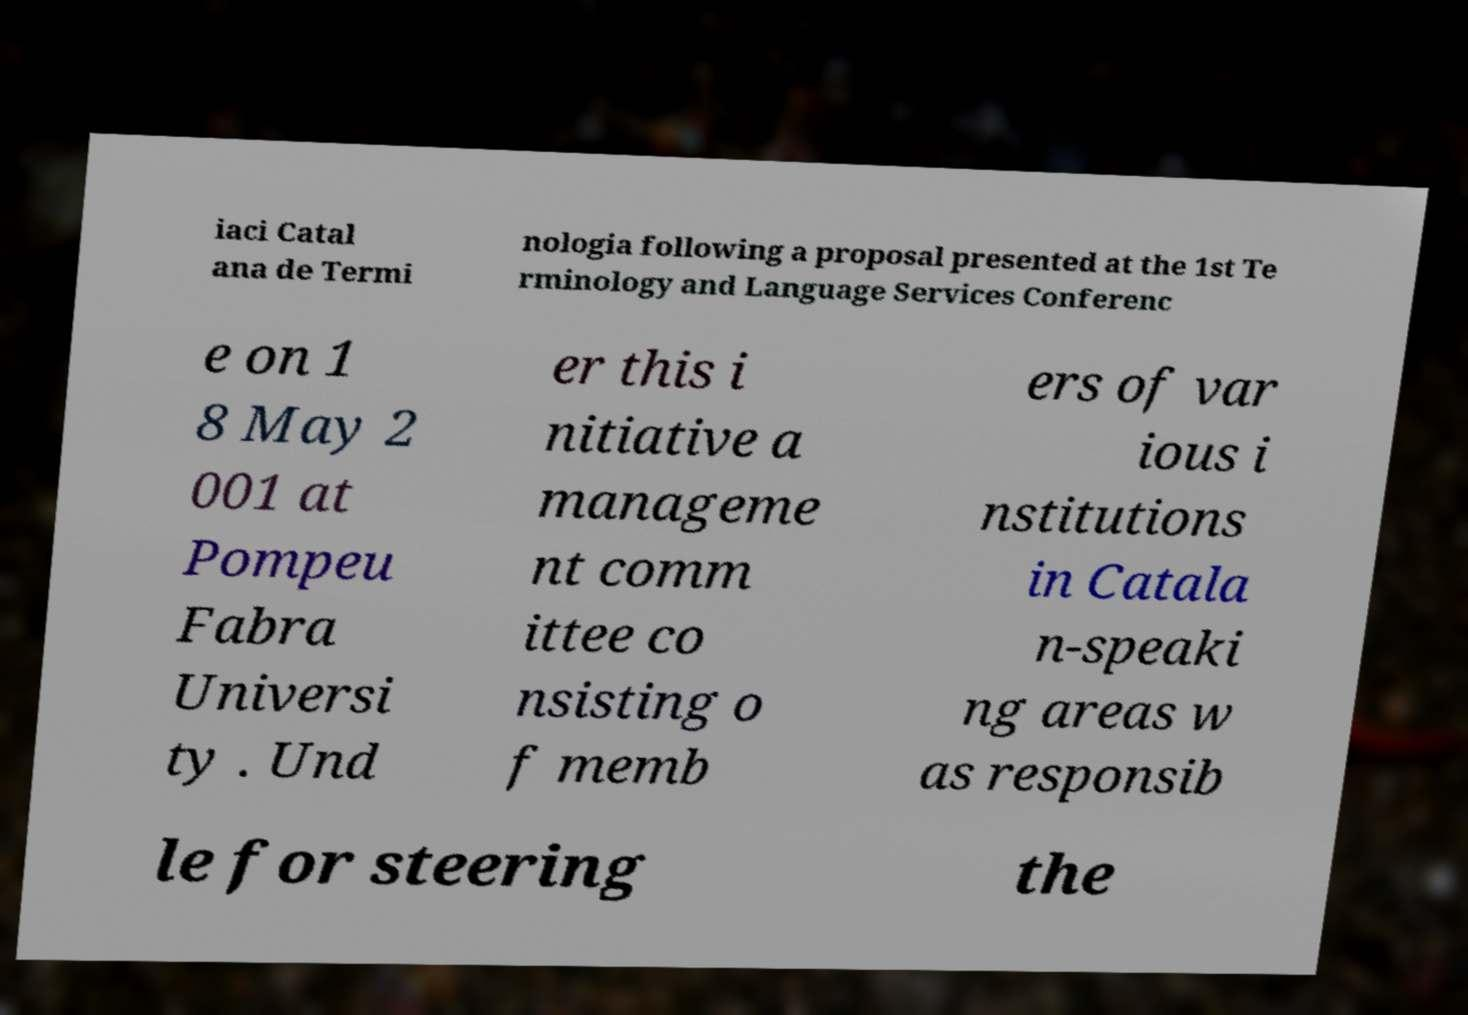Could you extract and type out the text from this image? iaci Catal ana de Termi nologia following a proposal presented at the 1st Te rminology and Language Services Conferenc e on 1 8 May 2 001 at Pompeu Fabra Universi ty . Und er this i nitiative a manageme nt comm ittee co nsisting o f memb ers of var ious i nstitutions in Catala n-speaki ng areas w as responsib le for steering the 